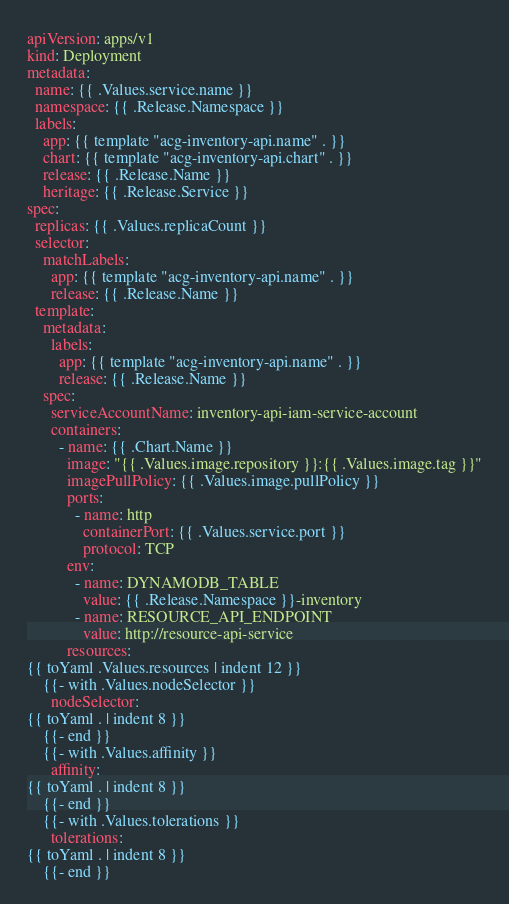Convert code to text. <code><loc_0><loc_0><loc_500><loc_500><_YAML_>apiVersion: apps/v1
kind: Deployment
metadata:
  name: {{ .Values.service.name }}
  namespace: {{ .Release.Namespace }}
  labels:
    app: {{ template "acg-inventory-api.name" . }}
    chart: {{ template "acg-inventory-api.chart" . }}
    release: {{ .Release.Name }}
    heritage: {{ .Release.Service }}
spec:
  replicas: {{ .Values.replicaCount }}
  selector:
    matchLabels:
      app: {{ template "acg-inventory-api.name" . }}
      release: {{ .Release.Name }}
  template:
    metadata:
      labels:
        app: {{ template "acg-inventory-api.name" . }}
        release: {{ .Release.Name }}
    spec:
      serviceAccountName: inventory-api-iam-service-account
      containers:
        - name: {{ .Chart.Name }}
          image: "{{ .Values.image.repository }}:{{ .Values.image.tag }}"
          imagePullPolicy: {{ .Values.image.pullPolicy }}
          ports:
            - name: http
              containerPort: {{ .Values.service.port }}
              protocol: TCP
          env:
            - name: DYNAMODB_TABLE 
              value: {{ .Release.Namespace }}-inventory
            - name: RESOURCE_API_ENDPOINT
              value: http://resource-api-service
          resources:
{{ toYaml .Values.resources | indent 12 }}
    {{- with .Values.nodeSelector }}
      nodeSelector:
{{ toYaml . | indent 8 }}
    {{- end }}
    {{- with .Values.affinity }}
      affinity:
{{ toYaml . | indent 8 }}
    {{- end }}
    {{- with .Values.tolerations }}
      tolerations:
{{ toYaml . | indent 8 }}
    {{- end }}
</code> 